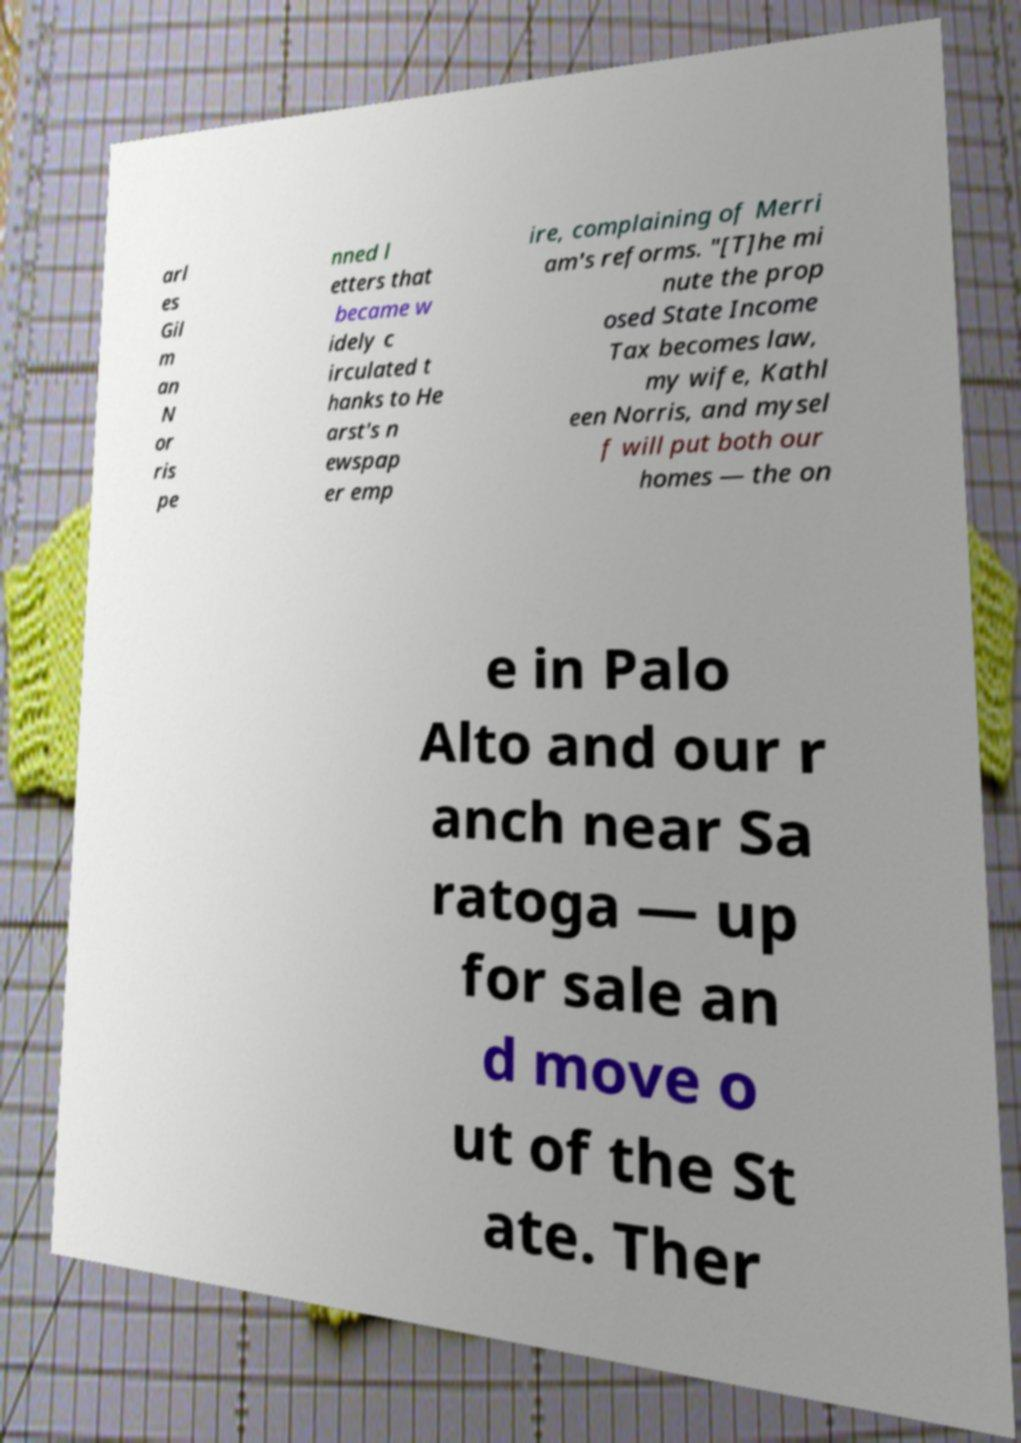I need the written content from this picture converted into text. Can you do that? arl es Gil m an N or ris pe nned l etters that became w idely c irculated t hanks to He arst's n ewspap er emp ire, complaining of Merri am's reforms. "[T]he mi nute the prop osed State Income Tax becomes law, my wife, Kathl een Norris, and mysel f will put both our homes — the on e in Palo Alto and our r anch near Sa ratoga — up for sale an d move o ut of the St ate. Ther 